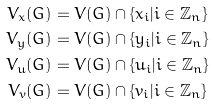<formula> <loc_0><loc_0><loc_500><loc_500>V _ { x } ( G ) & = V ( G ) \cap \{ x _ { i } | i \in \mathbb { Z } _ { n } \} \\ V _ { y } ( G ) & = V ( G ) \cap \{ y _ { i } | i \in \mathbb { Z } _ { n } \} \\ V _ { u } ( G ) & = V ( G ) \cap \{ u _ { i } | i \in \mathbb { Z } _ { n } \} \\ V _ { v } ( G ) & = V ( G ) \cap \{ v _ { i } | i \in \mathbb { Z } _ { n } \} \\</formula> 